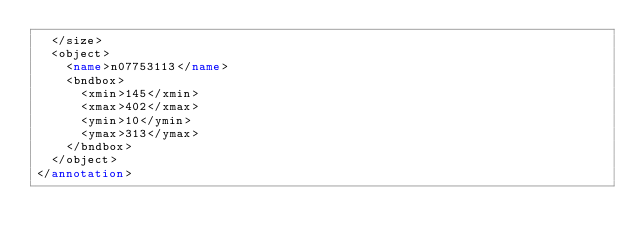<code> <loc_0><loc_0><loc_500><loc_500><_XML_>	</size>
	<object>
		<name>n07753113</name>
		<bndbox>
			<xmin>145</xmin>
			<xmax>402</xmax>
			<ymin>10</ymin>
			<ymax>313</ymax>
		</bndbox>
	</object>
</annotation>
</code> 